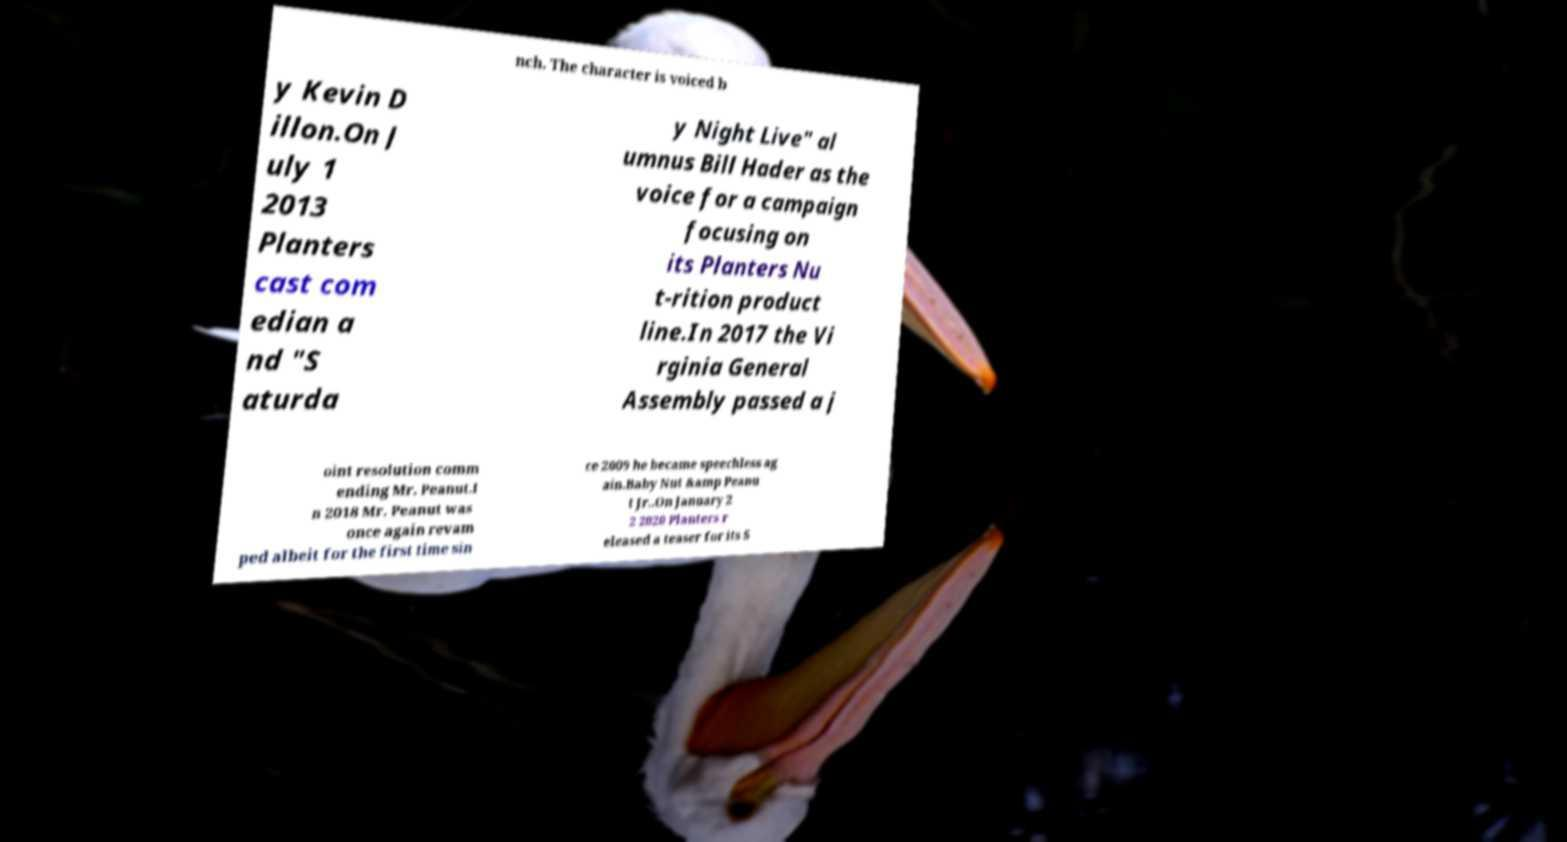For documentation purposes, I need the text within this image transcribed. Could you provide that? nch. The character is voiced b y Kevin D illon.On J uly 1 2013 Planters cast com edian a nd "S aturda y Night Live" al umnus Bill Hader as the voice for a campaign focusing on its Planters Nu t-rition product line.In 2017 the Vi rginia General Assembly passed a j oint resolution comm ending Mr. Peanut.I n 2018 Mr. Peanut was once again revam ped albeit for the first time sin ce 2009 he became speechless ag ain.Baby Nut &amp Peanu t Jr..On January 2 2 2020 Planters r eleased a teaser for its S 